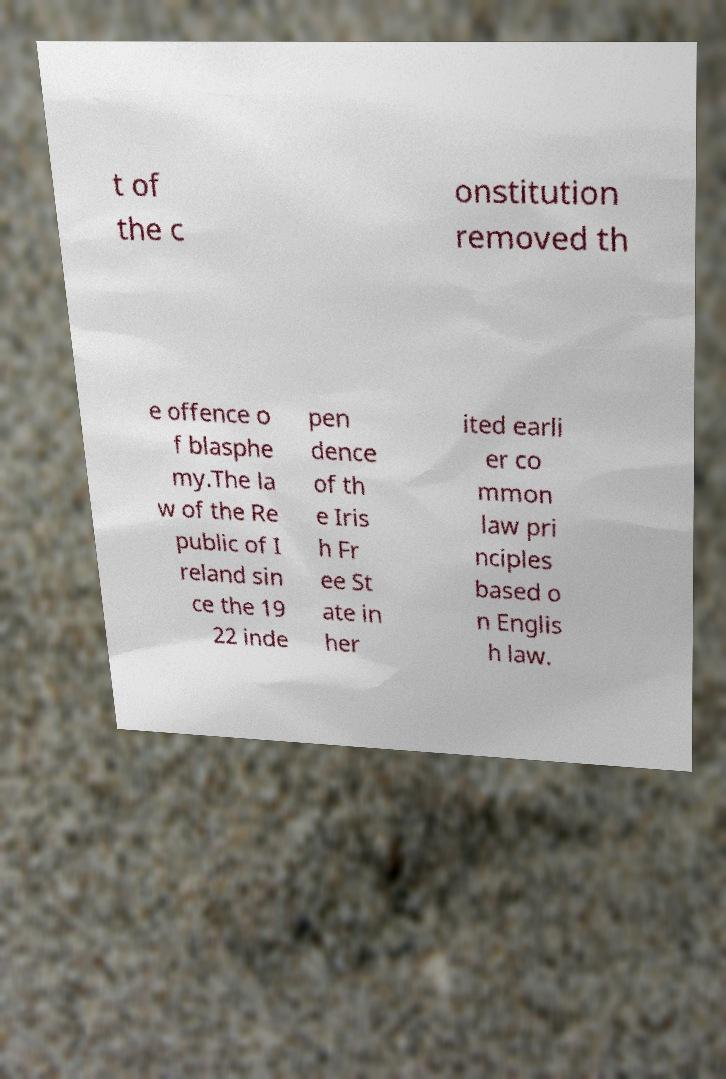Please read and relay the text visible in this image. What does it say? t of the c onstitution removed th e offence o f blasphe my.The la w of the Re public of I reland sin ce the 19 22 inde pen dence of th e Iris h Fr ee St ate in her ited earli er co mmon law pri nciples based o n Englis h law. 